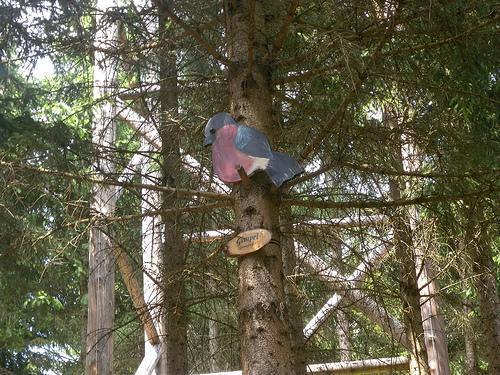How many colors is the bird?
Give a very brief answer. 3. How many birds are there?
Give a very brief answer. 1. 